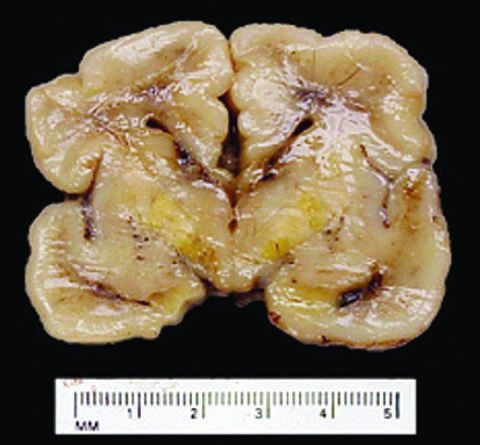what is less developed in the neonatal period than it is in adulthood?
Answer the question using a single word or phrase. The blood-brain barrier 